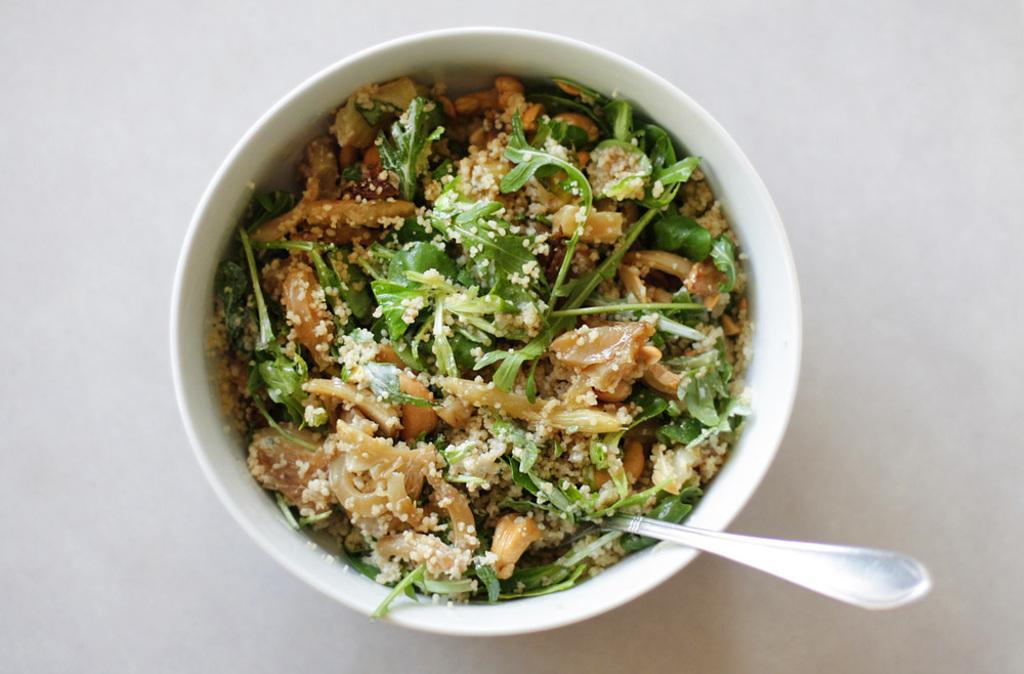Please provide a concise description of this image. In this picture, there is a bowl with food and spoon. 